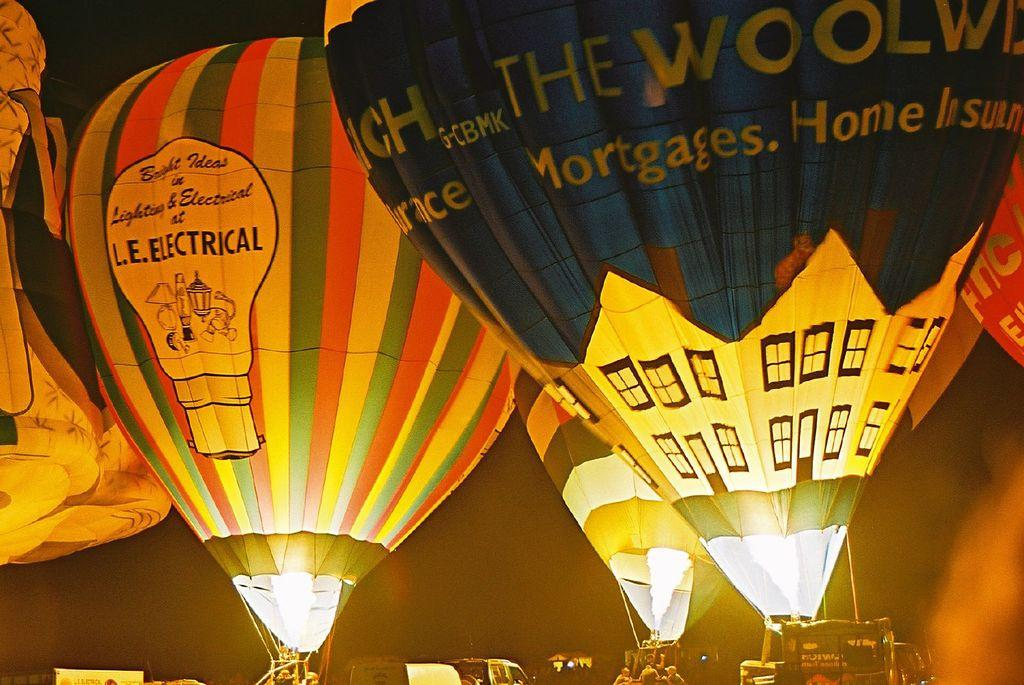What is the main subject of the image? The main subject of the image is hot air balloons. Can you describe the appearance of the hot air balloons? The hot air balloons are colorful. What else can be seen in the image besides the hot air balloons? There are people near the hot air balloons and vehicles in the image. What is the color of the background in the image? The background of the image is black. What type of plastic material can be seen on the roof in the image? There is no roof or plastic material present in the image; it features hot air balloons and their surroundings. 